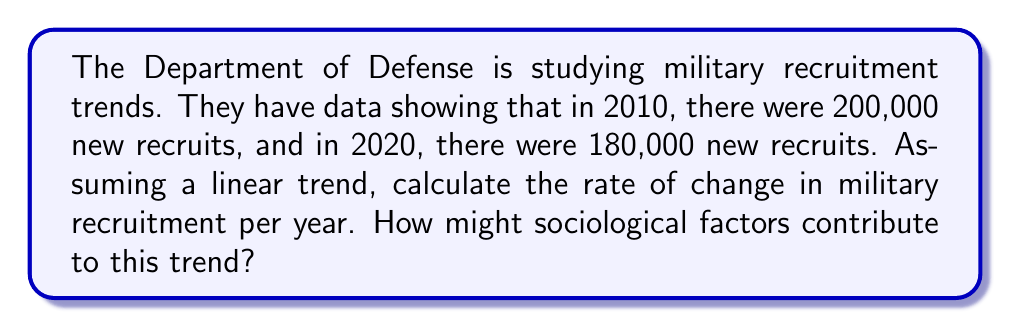What is the answer to this math problem? To solve this problem, we'll use a linear function and calculate its slope, which represents the rate of change. Let's approach this step-by-step:

1) Define our variables:
   $x$ = years since 2010
   $y$ = number of new recruits

2) We have two data points:
   $(0, 200000)$ for 2010
   $(10, 180000)$ for 2020

3) The slope formula for a linear function is:

   $$m = \frac{y_2 - y_1}{x_2 - x_1}$$

4) Plugging in our values:

   $$m = \frac{180000 - 200000}{10 - 0} = \frac{-20000}{10} = -2000$$

5) This means the rate of change is -2000 recruits per year.

6) We can express this as a linear function:

   $$y = -2000x + 200000$$

   Where $y$ is the number of recruits and $x$ is the number of years since 2010.

From a sociological perspective, this declining trend could be attributed to various factors:
- Changing attitudes towards military service
- Economic conditions affecting job markets
- Demographic shifts in the eligible population
- Changes in education opportunities
- Evolving perceptions of national security

Understanding these sociological factors could provide valuable insights into military recruitment dynamics and help in developing strategies to address the declining trend.
Answer: -2000 recruits/year 